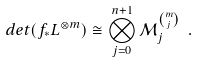Convert formula to latex. <formula><loc_0><loc_0><loc_500><loc_500>d e t ( f _ { * } L ^ { \otimes m } ) \cong \bigotimes _ { j = 0 } ^ { n + 1 } \mathcal { M } _ { j } ^ { \binom { m } { j } } \ .</formula> 